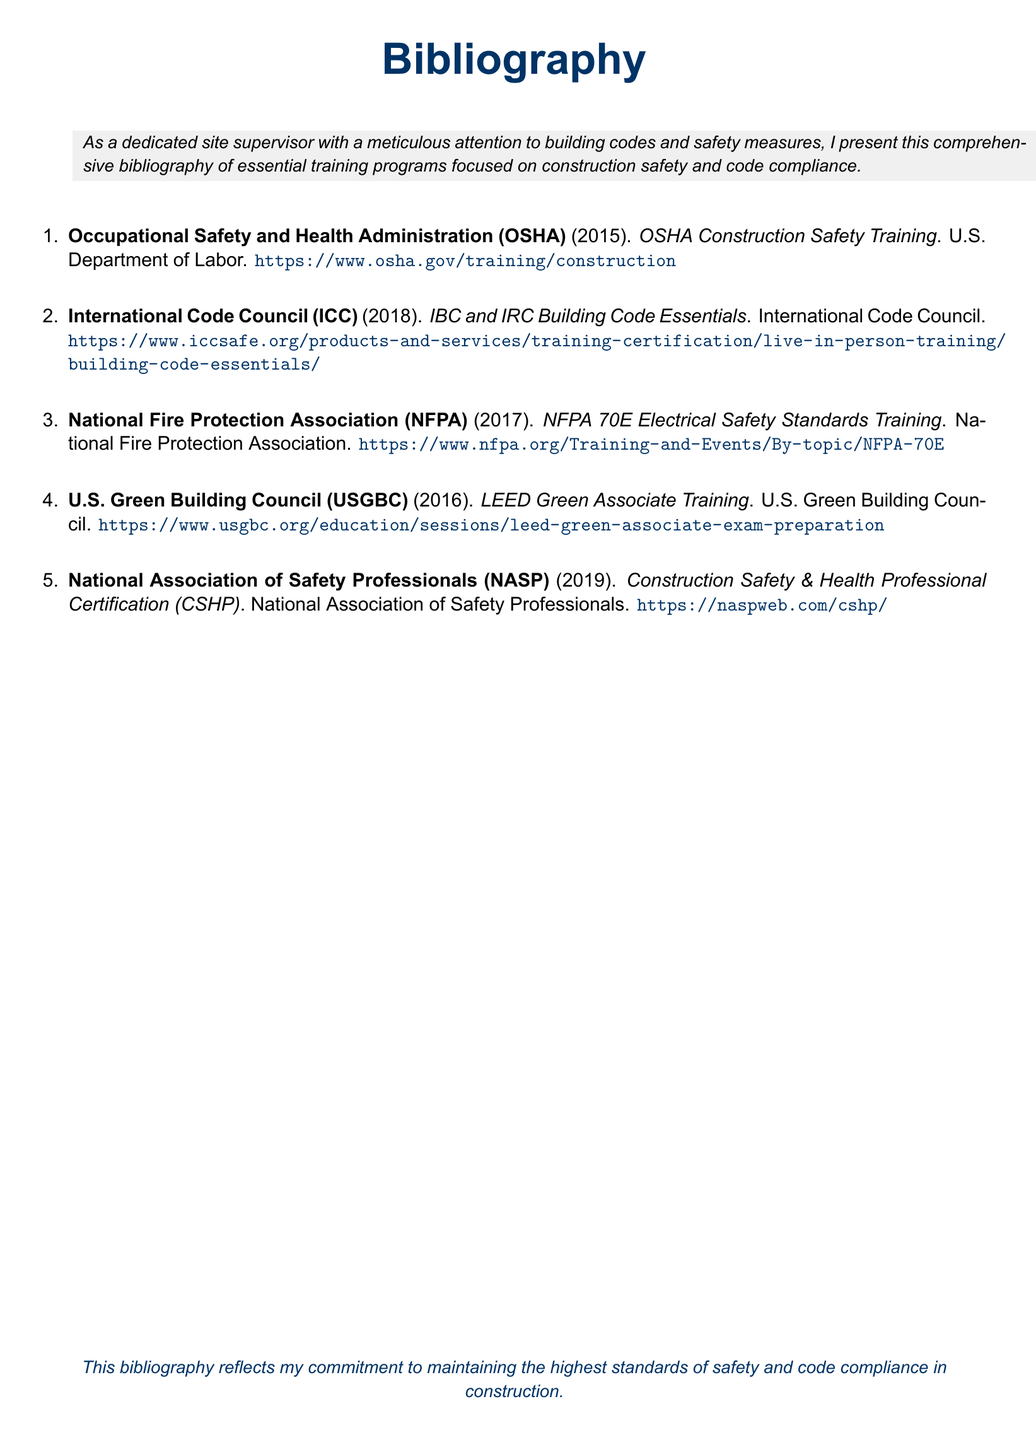What is the title of the document? The title is presented at the beginning of the document and indicates it is a bibliography focused on training programs.
Answer: Bibliography Who published the OSHA Construction Safety Training program? This information can be found under the respective entry in the bibliography, specifically the authoring organization.
Answer: U.S. Department of Labor In what year was the IBC and IRC Building Code Essentials published? The publication date is indicated next to the title of the training program.
Answer: 2018 What is the URL for the NFPA 70E Electrical Safety Standards Training? The URL is provided in the entry for the relevant training program and refers to the specific web page.
Answer: https://www.nfpa.org/Training-and-Events/By-topic/NFPA-70E How many training programs are listed in the bibliography? The total number of entries can be calculated by counting them in the list.
Answer: 5 What organization offers the Construction Safety & Health Professional Certification? This detail is available in the entry for the relevant training program.
Answer: National Association of Safety Professionals Which training program was published in 2016? The publication year indicates when the training was released in the bibliography.
Answer: LEED Green Associate Training What color is used for the document's background? The background color is specified and provides a visual aspect of the document format.
Answer: White What commitment does the author express in the summary? The summary at the end conveys the author's dedication to a particular principle in construction.
Answer: Safety and code compliance 